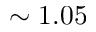<formula> <loc_0><loc_0><loc_500><loc_500>\sim 1 . 0 5</formula> 